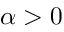Convert formula to latex. <formula><loc_0><loc_0><loc_500><loc_500>\alpha > 0</formula> 